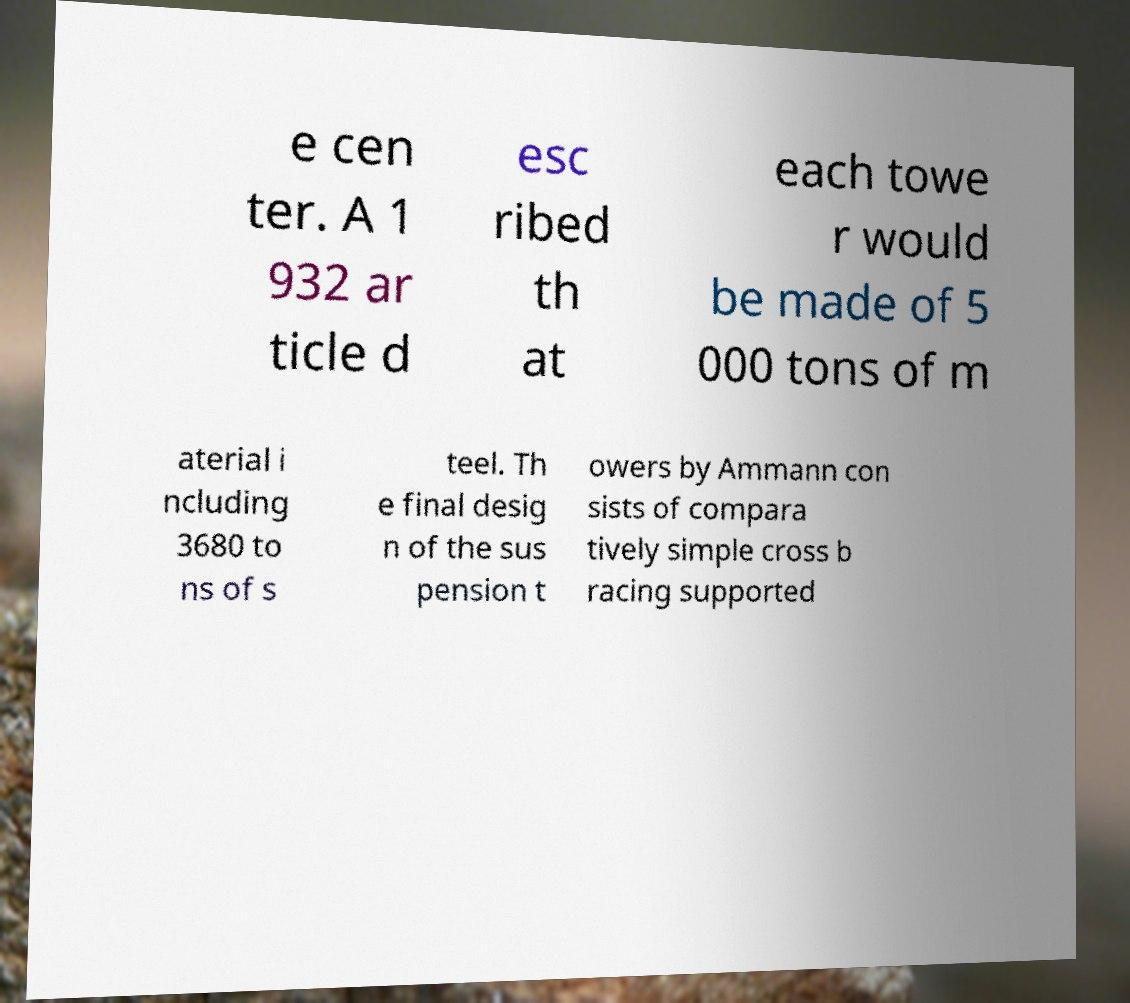There's text embedded in this image that I need extracted. Can you transcribe it verbatim? e cen ter. A 1 932 ar ticle d esc ribed th at each towe r would be made of 5 000 tons of m aterial i ncluding 3680 to ns of s teel. Th e final desig n of the sus pension t owers by Ammann con sists of compara tively simple cross b racing supported 